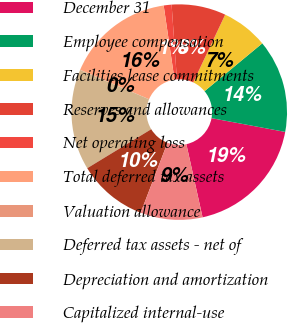Convert chart. <chart><loc_0><loc_0><loc_500><loc_500><pie_chart><fcel>December 31<fcel>Employee compensation<fcel>Facilities lease commitments<fcel>Reserves and allowances<fcel>Net operating loss<fcel>Total deferred tax assets<fcel>Valuation allowance<fcel>Deferred tax assets - net of<fcel>Depreciation and amortization<fcel>Capitalized internal-use<nl><fcel>18.59%<fcel>13.95%<fcel>6.98%<fcel>8.14%<fcel>1.18%<fcel>16.27%<fcel>0.02%<fcel>15.11%<fcel>10.46%<fcel>9.3%<nl></chart> 